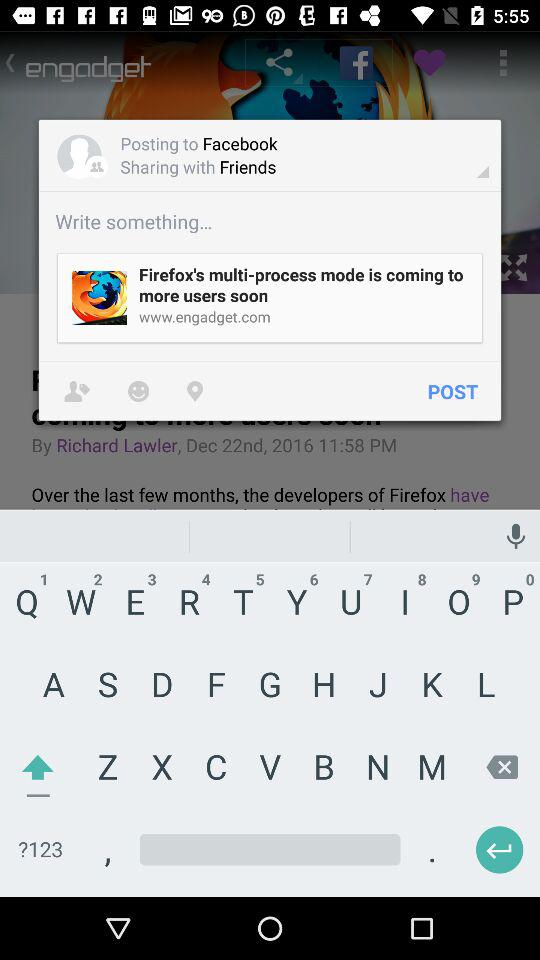How many more items are there in the second section than the first?
Answer the question using a single word or phrase. 2 